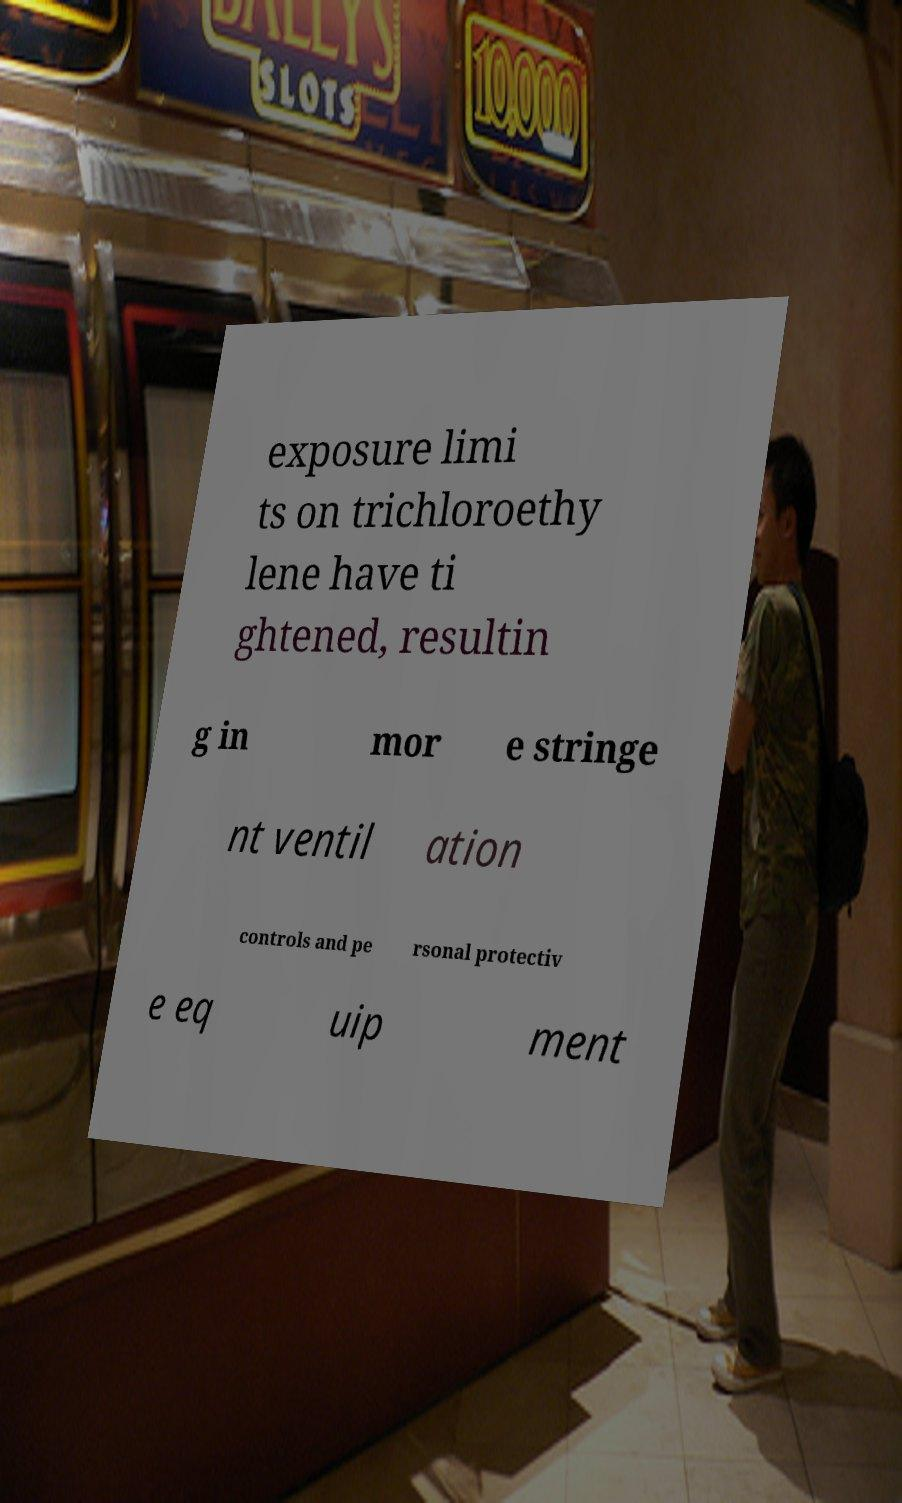I need the written content from this picture converted into text. Can you do that? exposure limi ts on trichloroethy lene have ti ghtened, resultin g in mor e stringe nt ventil ation controls and pe rsonal protectiv e eq uip ment 